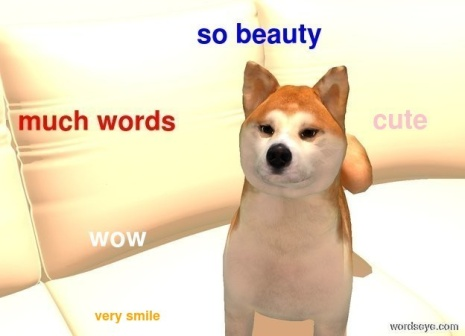Describe a day in the life of this Shiba Inu. A day in the life of this Shiba Inu would start with a good stretch and a big yawn as it wakes up from a cozy sleep on its favorite couch. Its spirited nature means it enjoys an energetic play session first thing in the morning, running around the house with its toys. After working up an appetite, it eagerly awaits breakfast, possibly some high-quality kibble with a treat on the side. Post-breakfast, the Shiba Inu would likely enjoy a leisurely walk around the neighborhood, sniffing every intriguing scent and perhaps making a few furry friends along the way.

Returning home, it might settle down for some quiet time, lounging on the couch as it observes the household activities. Its playful spirit would resurface later in the day with more interactive games or a fun training session with its human. As evening approaches, it enjoys a hearty dinner before curling up once again on the white couch, where the cycle of rest, play, and adoration continues. Throughout the day, its gleaming eyes and charming smile constantly win over hearts, making every moment with this delightful Shiba Inu special.  What magical powers might this Shiba Inu possess in a fantasy world? In a fantasy world, this Shiba Inu could be an enchanting guardian of the forest, possessing the magical power to communicate with all woodland creatures. With a single bark, it could summon the animals to gather for a grand assembly, each one eager to listen to their beloved protector. Its eyes, gleaming with mystic light, might have the ability to heal wounds and bring life back to withered plants, ensuring the forest thrives under its watchful care.

The floating words around its head could spell out enchantments, casting protective barriers against any unwelcome intruders, while its playful spirit could bring laughter and joy to all who encounter it. This Shiba Inu's magical powers would create a harmonious and vibrant world where nature and magic coexist beautifully, making it a cherished figure in the realm of fantasy.  In what realistic scenario do you think this picture could have been taken? This picture might have been taken during a lazy afternoon at home, where the Shiba Inu enjoys relaxing on its favorite couch. Its human companion, amused by the dog's charming presence, decides to add a touch of humor to the moment by overlaying playful text on the photo. The resulting image captures the light-hearted and affectionate bond between the pet and its owner.  Imagine this Shiba Inu is part of a family outing. Describe that scene. During a family outing, this Shiba Inu would be the enthusiastic leader, exploring new sights and smells with boundless energy. The family may have chosen to spend the day at a picturesque park with vast green fields and serene pathways. The Shiba Inu, trotting confidently with its leash held by a family member, has a joyful expression as it wags its tail in excitement.

Children in the family might be running alongside the dog, playing fetch and laughing as the Shiba Inu keenly chases after a thrown ball. The parents, meanwhile, capture these joyful moments on camera, proud of the happiness their furry companion brings to their lives. The outing would also involve a delightful picnic where the Shiba Inu, after its vigorous playtime, would settle down beside the family, enjoying tummy rubs and the occasional treat while basking in the love and joy surrounding it. This idyllic scene showcases the harmony and affection that the Shiba Inu shares with its human family, making it a cherished part of their lives. 